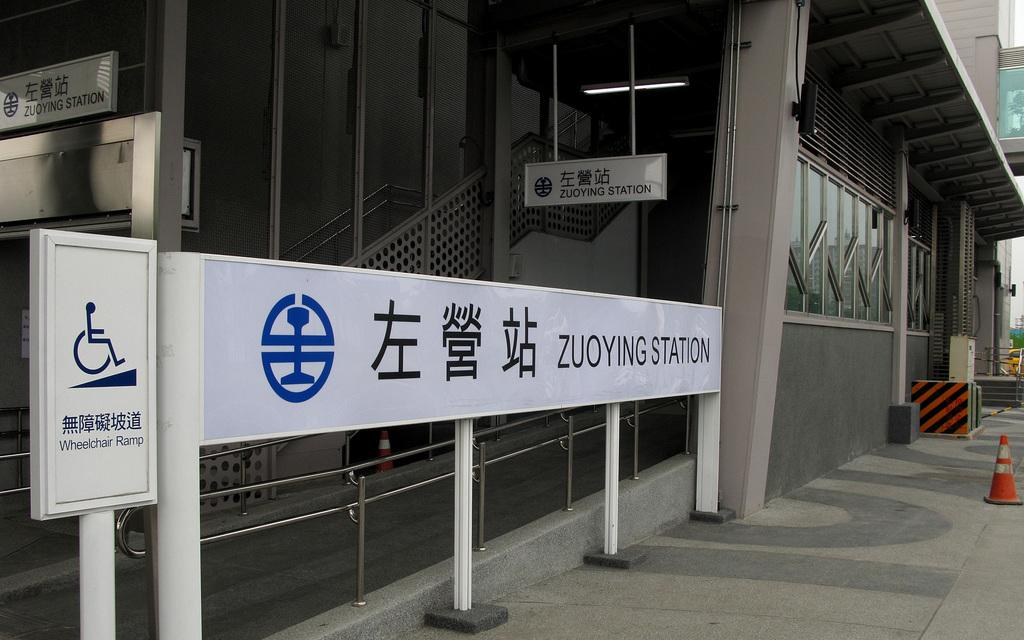What type of surface is visible in the image? There is a pavement in the image. What can be seen in the distance in the image? There is a building in the background of the image. What object is present in the image with a flat surface? There is a board in the image. What is written or displayed on the board? There is text on the board. What type of bead is used to decorate the roof in the image? There is no roof or bead present in the image. What type of patch is visible on the board in the image? There is no patch visible on the board in the image; it only has text. 